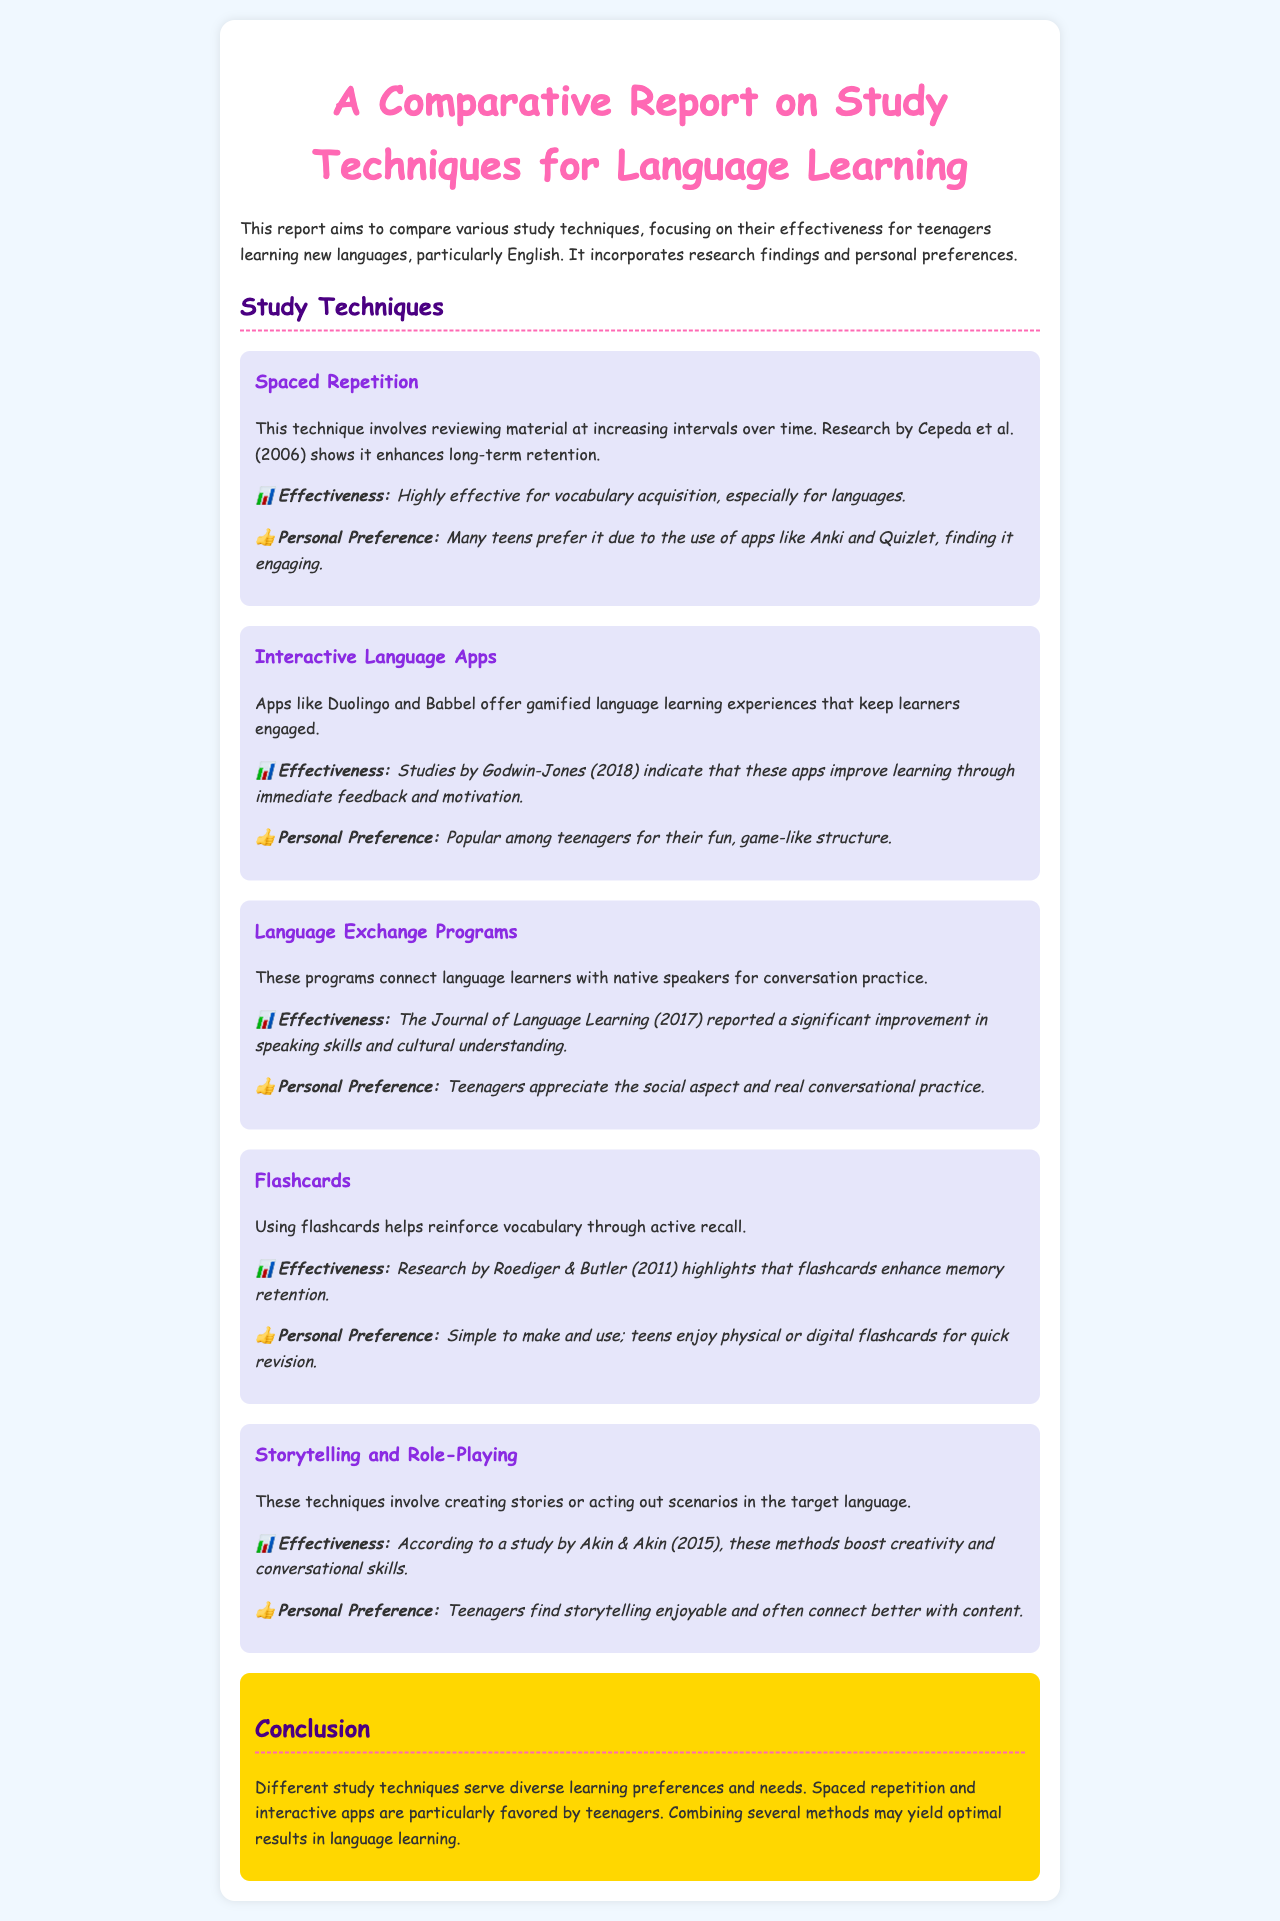What is the main focus of the report? The report compares various study techniques, particularly for teenagers learning new languages, especially English.
Answer: Study techniques for teenagers learning new languages Who conducted the research on spaced repetition? The research on spaced repetition was conducted by Cepeda et al.
Answer: Cepeda et al Which study technique is described as enhancing long-term retention? The technique that enhances long-term retention is spaced repetition.
Answer: Spaced repetition What apps are mentioned as interactive language apps? The apps mentioned are Duolingo and Babbel.
Answer: Duolingo and Babbel What is a significant benefit of language exchange programs? They improve speaking skills and cultural understanding.
Answer: Improvement in speaking skills and cultural understanding How do teenagers feel about storytelling as a study technique? Teenagers find storytelling enjoyable.
Answer: Enjoyable What method is highlighted for reinforcing vocabulary? The method highlighted for reinforcing vocabulary is using flashcards.
Answer: Using flashcards What is stated about combining study methods? Combining several methods may yield optimal results in language learning.
Answer: Optimal results in language learning What did the research by Roediger & Butler highlight? It highlighted that flashcards enhance memory retention.
Answer: Enhance memory retention 